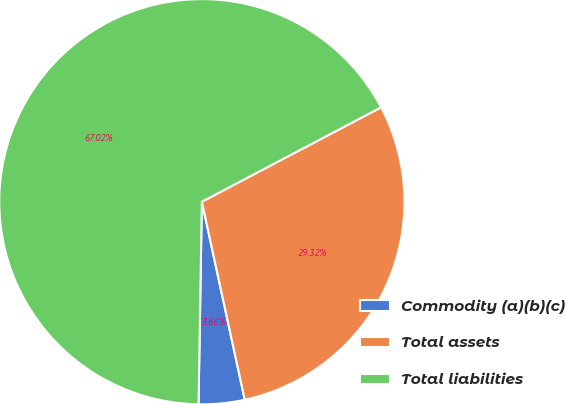<chart> <loc_0><loc_0><loc_500><loc_500><pie_chart><fcel>Commodity (a)(b)(c)<fcel>Total assets<fcel>Total liabilities<nl><fcel>3.66%<fcel>29.32%<fcel>67.02%<nl></chart> 